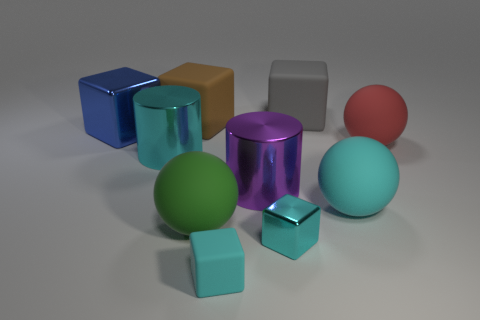Subtract all green cylinders. How many cyan blocks are left? 2 Subtract all small shiny blocks. How many blocks are left? 4 Subtract all brown cubes. How many cubes are left? 4 Subtract all yellow cubes. Subtract all yellow cylinders. How many cubes are left? 5 Subtract all spheres. How many objects are left? 7 Add 5 small cyan metal blocks. How many small cyan metal blocks exist? 6 Subtract 0 yellow spheres. How many objects are left? 10 Subtract all large purple cylinders. Subtract all big blue objects. How many objects are left? 8 Add 8 large blue metal blocks. How many large blue metal blocks are left? 9 